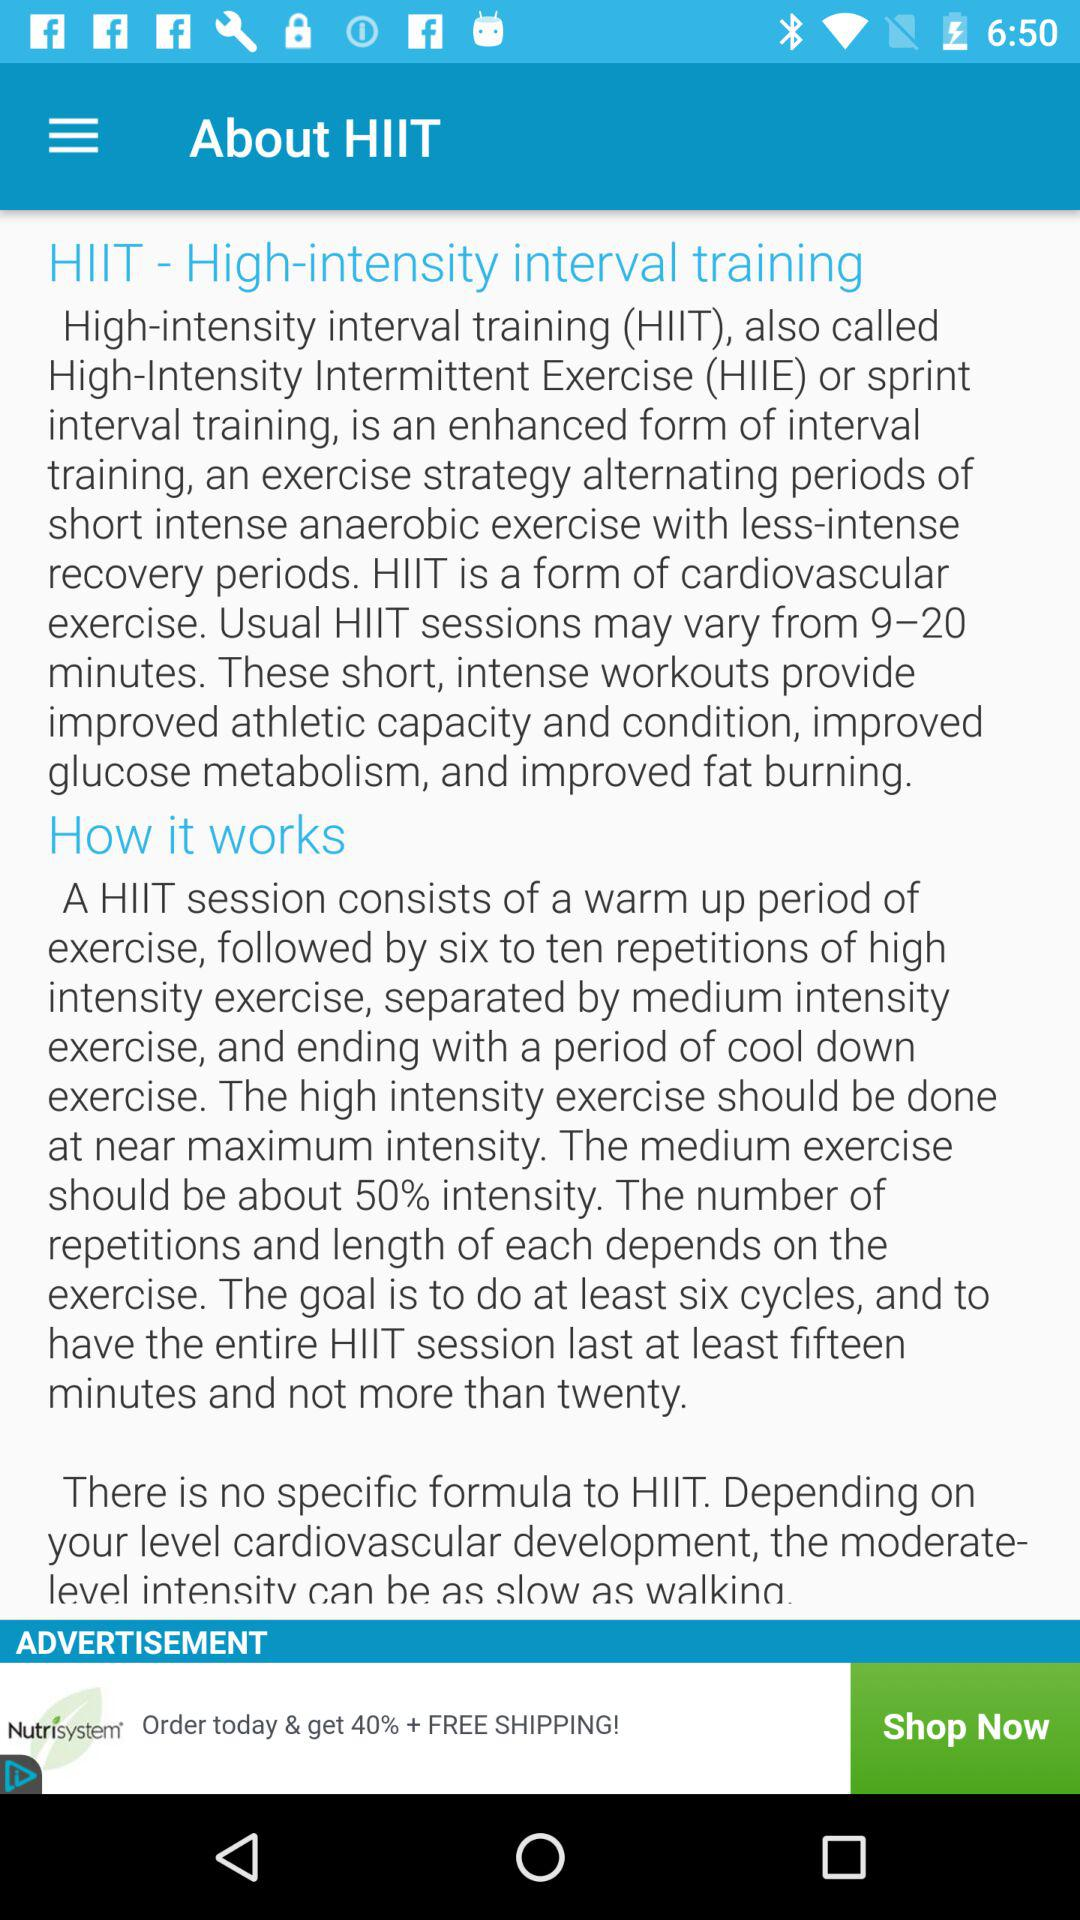What should be the intensity of medium-intensity exercise? The intensity of medium-intensity exercise is about 50%. 